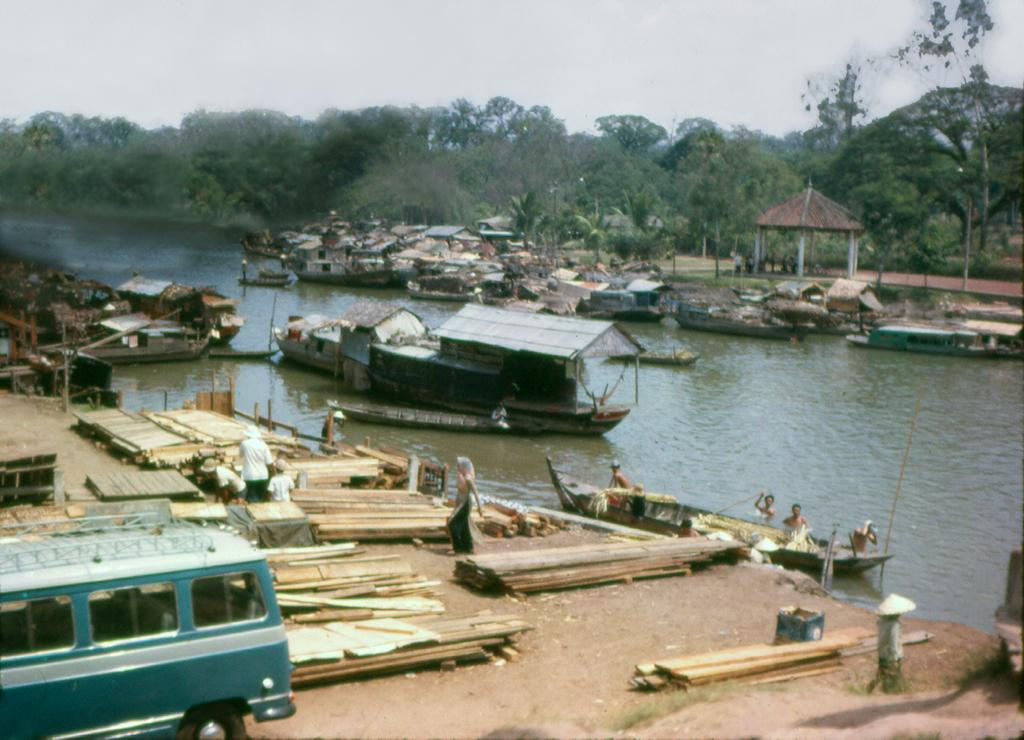What type of vehicle is in the image? There is a van in the image. What objects can be seen near the van? There are wooden planks visible in the image. Who or what else is in the image? There are people and boats in the image. What can be seen in the background of the image? Water and trees are visible in the background of the image. How many cakes are being held by the cattle in the image? There are no cattle or cakes present in the image. 